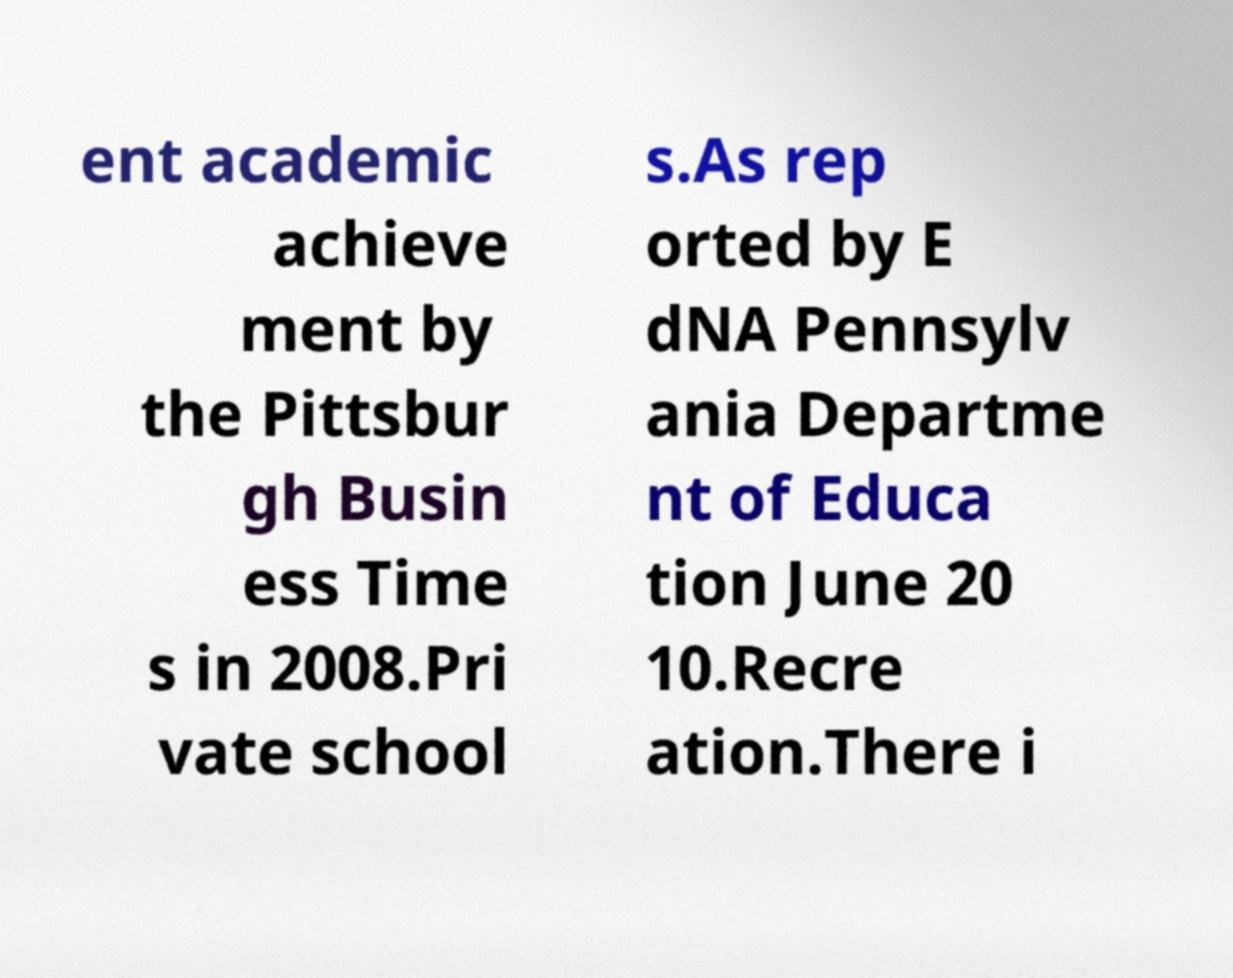Please read and relay the text visible in this image. What does it say? ent academic achieve ment by the Pittsbur gh Busin ess Time s in 2008.Pri vate school s.As rep orted by E dNA Pennsylv ania Departme nt of Educa tion June 20 10.Recre ation.There i 